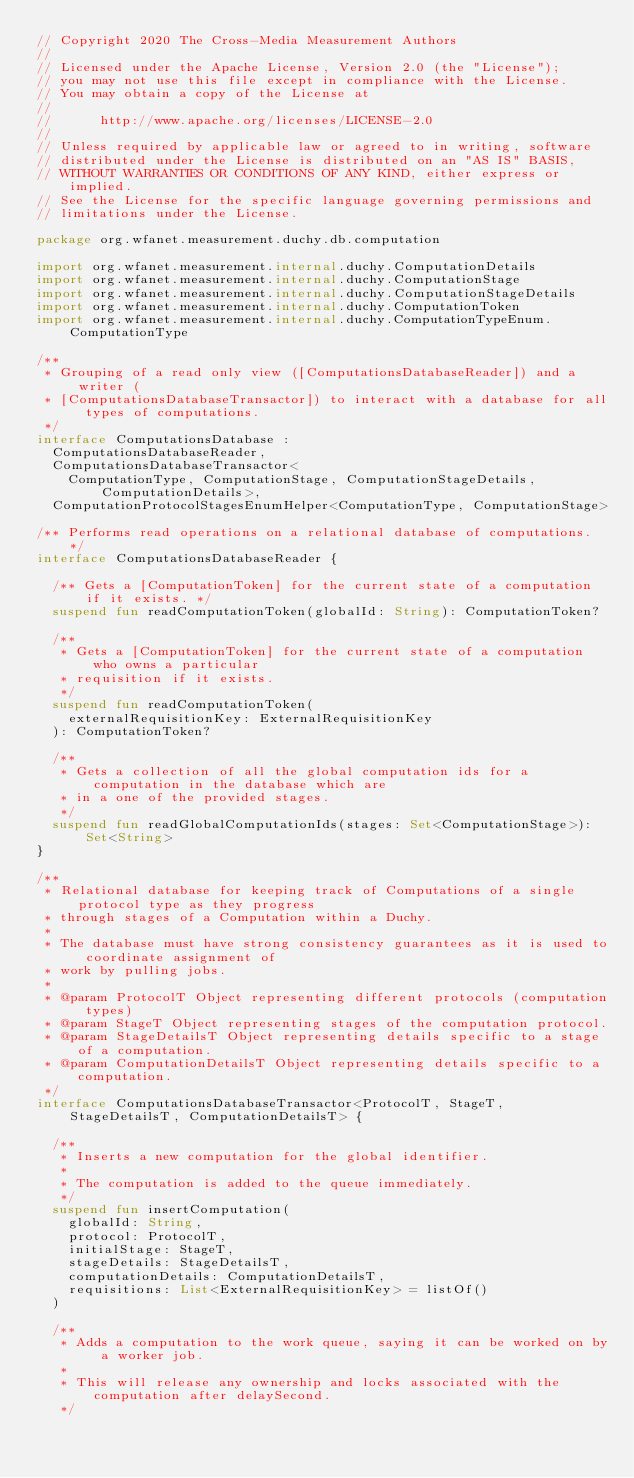Convert code to text. <code><loc_0><loc_0><loc_500><loc_500><_Kotlin_>// Copyright 2020 The Cross-Media Measurement Authors
//
// Licensed under the Apache License, Version 2.0 (the "License");
// you may not use this file except in compliance with the License.
// You may obtain a copy of the License at
//
//      http://www.apache.org/licenses/LICENSE-2.0
//
// Unless required by applicable law or agreed to in writing, software
// distributed under the License is distributed on an "AS IS" BASIS,
// WITHOUT WARRANTIES OR CONDITIONS OF ANY KIND, either express or implied.
// See the License for the specific language governing permissions and
// limitations under the License.

package org.wfanet.measurement.duchy.db.computation

import org.wfanet.measurement.internal.duchy.ComputationDetails
import org.wfanet.measurement.internal.duchy.ComputationStage
import org.wfanet.measurement.internal.duchy.ComputationStageDetails
import org.wfanet.measurement.internal.duchy.ComputationToken
import org.wfanet.measurement.internal.duchy.ComputationTypeEnum.ComputationType

/**
 * Grouping of a read only view ([ComputationsDatabaseReader]) and a writer (
 * [ComputationsDatabaseTransactor]) to interact with a database for all types of computations.
 */
interface ComputationsDatabase :
  ComputationsDatabaseReader,
  ComputationsDatabaseTransactor<
    ComputationType, ComputationStage, ComputationStageDetails, ComputationDetails>,
  ComputationProtocolStagesEnumHelper<ComputationType, ComputationStage>

/** Performs read operations on a relational database of computations. */
interface ComputationsDatabaseReader {

  /** Gets a [ComputationToken] for the current state of a computation if it exists. */
  suspend fun readComputationToken(globalId: String): ComputationToken?

  /**
   * Gets a [ComputationToken] for the current state of a computation who owns a particular
   * requisition if it exists.
   */
  suspend fun readComputationToken(
    externalRequisitionKey: ExternalRequisitionKey
  ): ComputationToken?

  /**
   * Gets a collection of all the global computation ids for a computation in the database which are
   * in a one of the provided stages.
   */
  suspend fun readGlobalComputationIds(stages: Set<ComputationStage>): Set<String>
}

/**
 * Relational database for keeping track of Computations of a single protocol type as they progress
 * through stages of a Computation within a Duchy.
 *
 * The database must have strong consistency guarantees as it is used to coordinate assignment of
 * work by pulling jobs.
 *
 * @param ProtocolT Object representing different protocols (computation types)
 * @param StageT Object representing stages of the computation protocol.
 * @param StageDetailsT Object representing details specific to a stage of a computation.
 * @param ComputationDetailsT Object representing details specific to a computation.
 */
interface ComputationsDatabaseTransactor<ProtocolT, StageT, StageDetailsT, ComputationDetailsT> {

  /**
   * Inserts a new computation for the global identifier.
   *
   * The computation is added to the queue immediately.
   */
  suspend fun insertComputation(
    globalId: String,
    protocol: ProtocolT,
    initialStage: StageT,
    stageDetails: StageDetailsT,
    computationDetails: ComputationDetailsT,
    requisitions: List<ExternalRequisitionKey> = listOf()
  )

  /**
   * Adds a computation to the work queue, saying it can be worked on by a worker job.
   *
   * This will release any ownership and locks associated with the computation after delaySecond.
   */</code> 